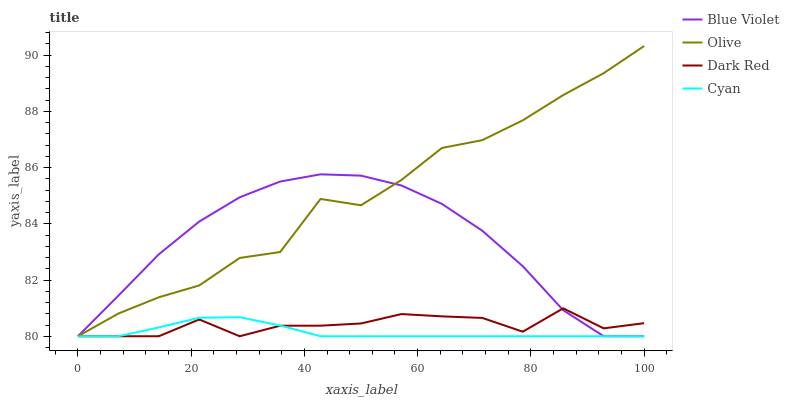Does Cyan have the minimum area under the curve?
Answer yes or no. Yes. Does Olive have the maximum area under the curve?
Answer yes or no. Yes. Does Dark Red have the minimum area under the curve?
Answer yes or no. No. Does Dark Red have the maximum area under the curve?
Answer yes or no. No. Is Cyan the smoothest?
Answer yes or no. Yes. Is Olive the roughest?
Answer yes or no. Yes. Is Dark Red the smoothest?
Answer yes or no. No. Is Dark Red the roughest?
Answer yes or no. No. Does Olive have the lowest value?
Answer yes or no. Yes. Does Olive have the highest value?
Answer yes or no. Yes. Does Dark Red have the highest value?
Answer yes or no. No. Does Cyan intersect Blue Violet?
Answer yes or no. Yes. Is Cyan less than Blue Violet?
Answer yes or no. No. Is Cyan greater than Blue Violet?
Answer yes or no. No. 